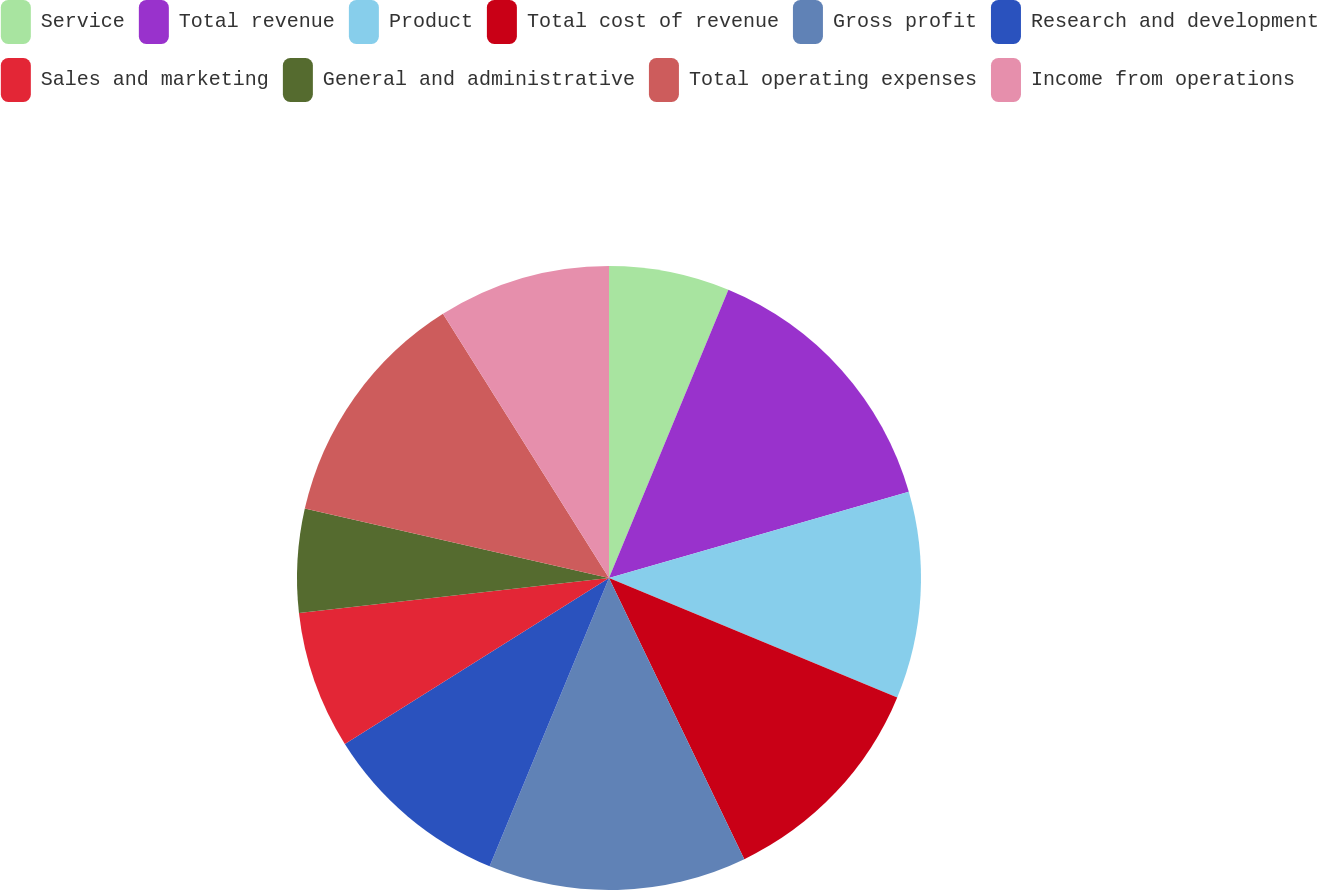Convert chart. <chart><loc_0><loc_0><loc_500><loc_500><pie_chart><fcel>Service<fcel>Total revenue<fcel>Product<fcel>Total cost of revenue<fcel>Gross profit<fcel>Research and development<fcel>Sales and marketing<fcel>General and administrative<fcel>Total operating expenses<fcel>Income from operations<nl><fcel>6.25%<fcel>14.29%<fcel>10.71%<fcel>11.61%<fcel>13.39%<fcel>9.82%<fcel>7.14%<fcel>5.36%<fcel>12.5%<fcel>8.93%<nl></chart> 